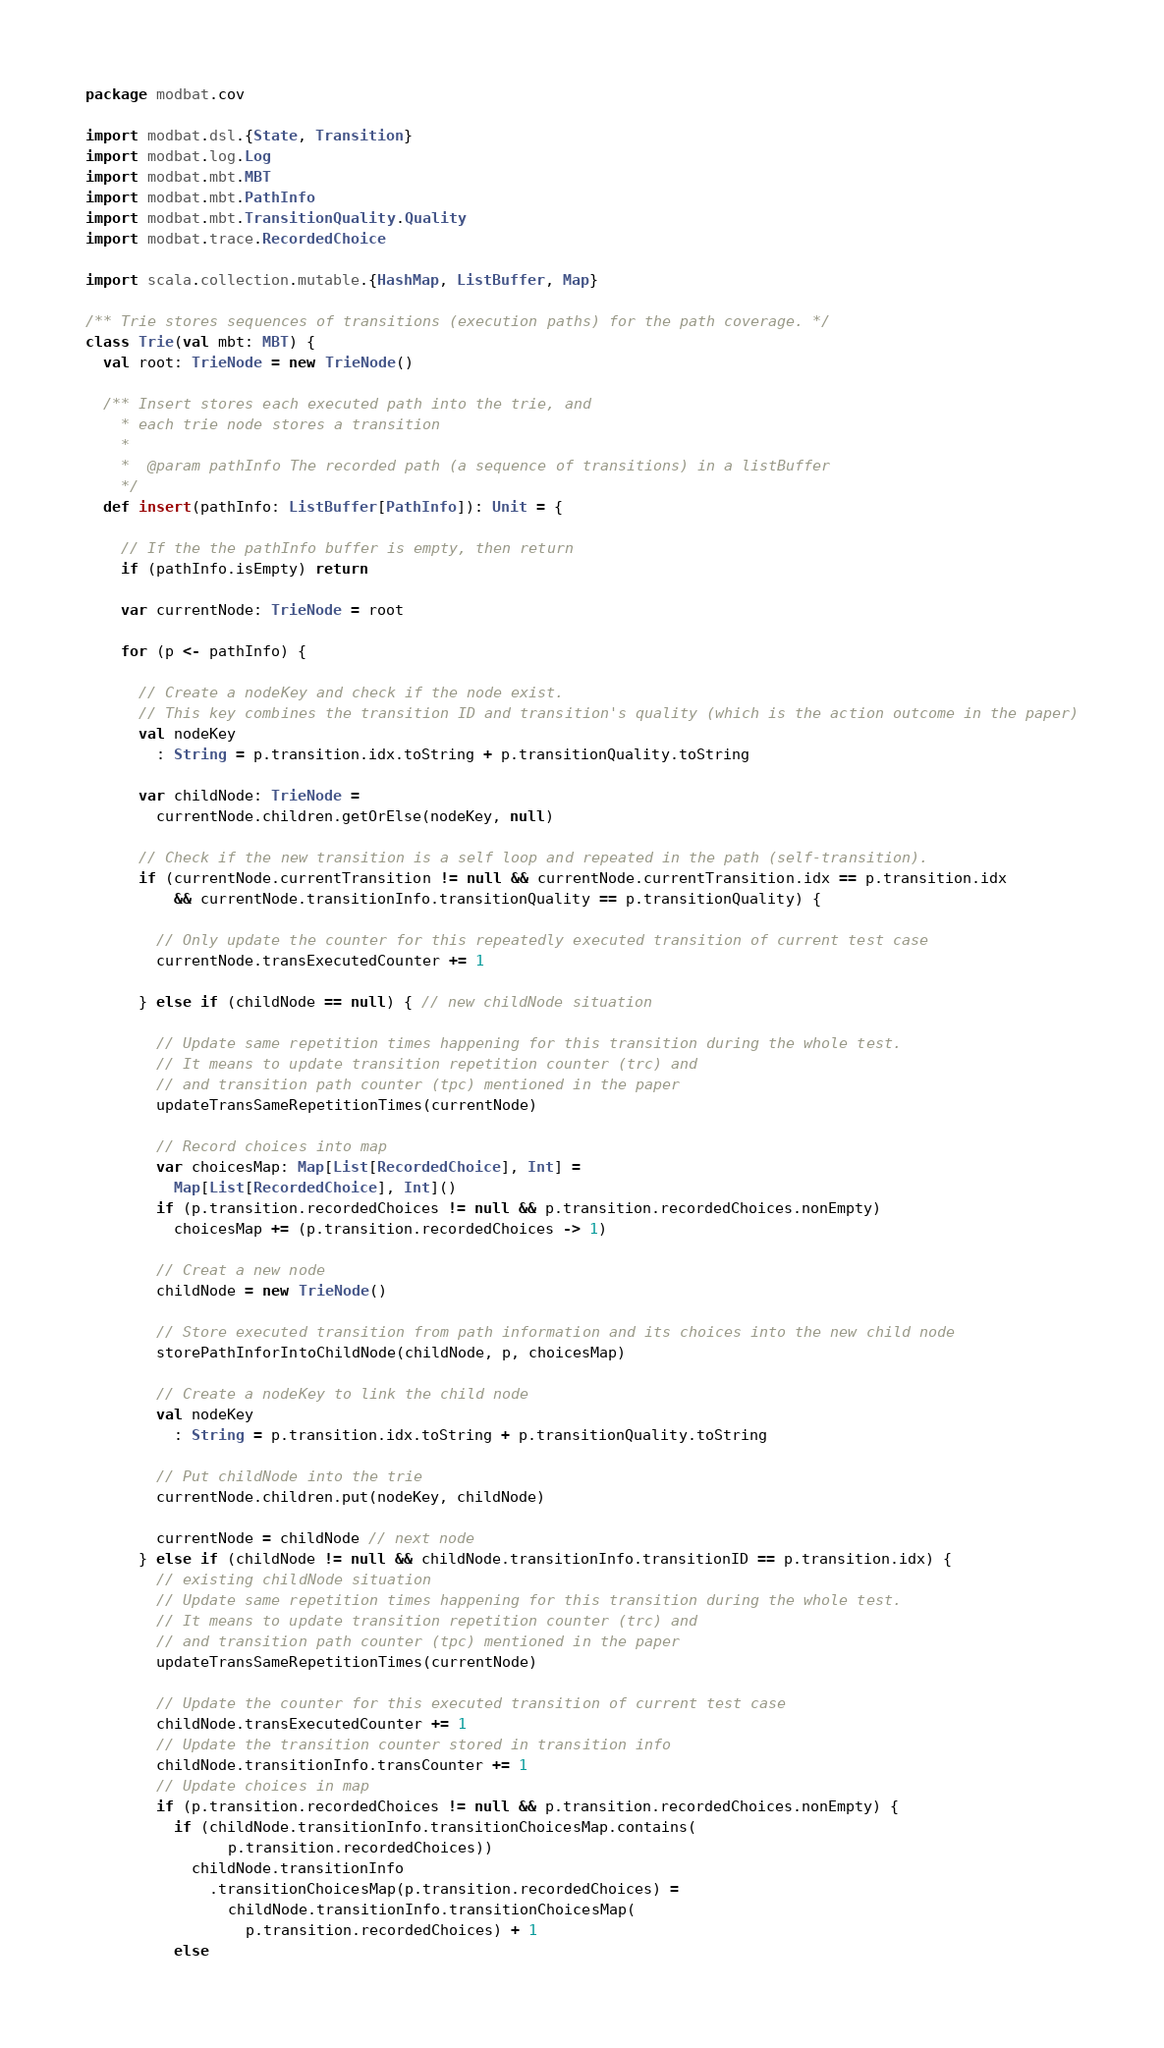<code> <loc_0><loc_0><loc_500><loc_500><_Scala_>package modbat.cov

import modbat.dsl.{State, Transition}
import modbat.log.Log
import modbat.mbt.MBT
import modbat.mbt.PathInfo
import modbat.mbt.TransitionQuality.Quality
import modbat.trace.RecordedChoice

import scala.collection.mutable.{HashMap, ListBuffer, Map}

/** Trie stores sequences of transitions (execution paths) for the path coverage. */
class Trie(val mbt: MBT) {
  val root: TrieNode = new TrieNode()

  /** Insert stores each executed path into the trie, and
    * each trie node stores a transition
    *
    *  @param pathInfo The recorded path (a sequence of transitions) in a listBuffer
    */
  def insert(pathInfo: ListBuffer[PathInfo]): Unit = {

    // If the the pathInfo buffer is empty, then return
    if (pathInfo.isEmpty) return

    var currentNode: TrieNode = root

    for (p <- pathInfo) {

      // Create a nodeKey and check if the node exist.
      // This key combines the transition ID and transition's quality (which is the action outcome in the paper)
      val nodeKey
        : String = p.transition.idx.toString + p.transitionQuality.toString

      var childNode: TrieNode =
        currentNode.children.getOrElse(nodeKey, null)

      // Check if the new transition is a self loop and repeated in the path (self-transition).
      if (currentNode.currentTransition != null && currentNode.currentTransition.idx == p.transition.idx
          && currentNode.transitionInfo.transitionQuality == p.transitionQuality) {

        // Only update the counter for this repeatedly executed transition of current test case
        currentNode.transExecutedCounter += 1

      } else if (childNode == null) { // new childNode situation

        // Update same repetition times happening for this transition during the whole test.
        // It means to update transition repetition counter (trc) and
        // and transition path counter (tpc) mentioned in the paper
        updateTransSameRepetitionTimes(currentNode)

        // Record choices into map
        var choicesMap: Map[List[RecordedChoice], Int] =
          Map[List[RecordedChoice], Int]()
        if (p.transition.recordedChoices != null && p.transition.recordedChoices.nonEmpty)
          choicesMap += (p.transition.recordedChoices -> 1)

        // Creat a new node
        childNode = new TrieNode()

        // Store executed transition from path information and its choices into the new child node
        storePathInforIntoChildNode(childNode, p, choicesMap)

        // Create a nodeKey to link the child node
        val nodeKey
          : String = p.transition.idx.toString + p.transitionQuality.toString

        // Put childNode into the trie
        currentNode.children.put(nodeKey, childNode)

        currentNode = childNode // next node
      } else if (childNode != null && childNode.transitionInfo.transitionID == p.transition.idx) {
        // existing childNode situation
        // Update same repetition times happening for this transition during the whole test.
        // It means to update transition repetition counter (trc) and
        // and transition path counter (tpc) mentioned in the paper
        updateTransSameRepetitionTimes(currentNode)

        // Update the counter for this executed transition of current test case
        childNode.transExecutedCounter += 1
        // Update the transition counter stored in transition info
        childNode.transitionInfo.transCounter += 1
        // Update choices in map
        if (p.transition.recordedChoices != null && p.transition.recordedChoices.nonEmpty) {
          if (childNode.transitionInfo.transitionChoicesMap.contains(
                p.transition.recordedChoices))
            childNode.transitionInfo
              .transitionChoicesMap(p.transition.recordedChoices) =
                childNode.transitionInfo.transitionChoicesMap(
                  p.transition.recordedChoices) + 1
          else</code> 